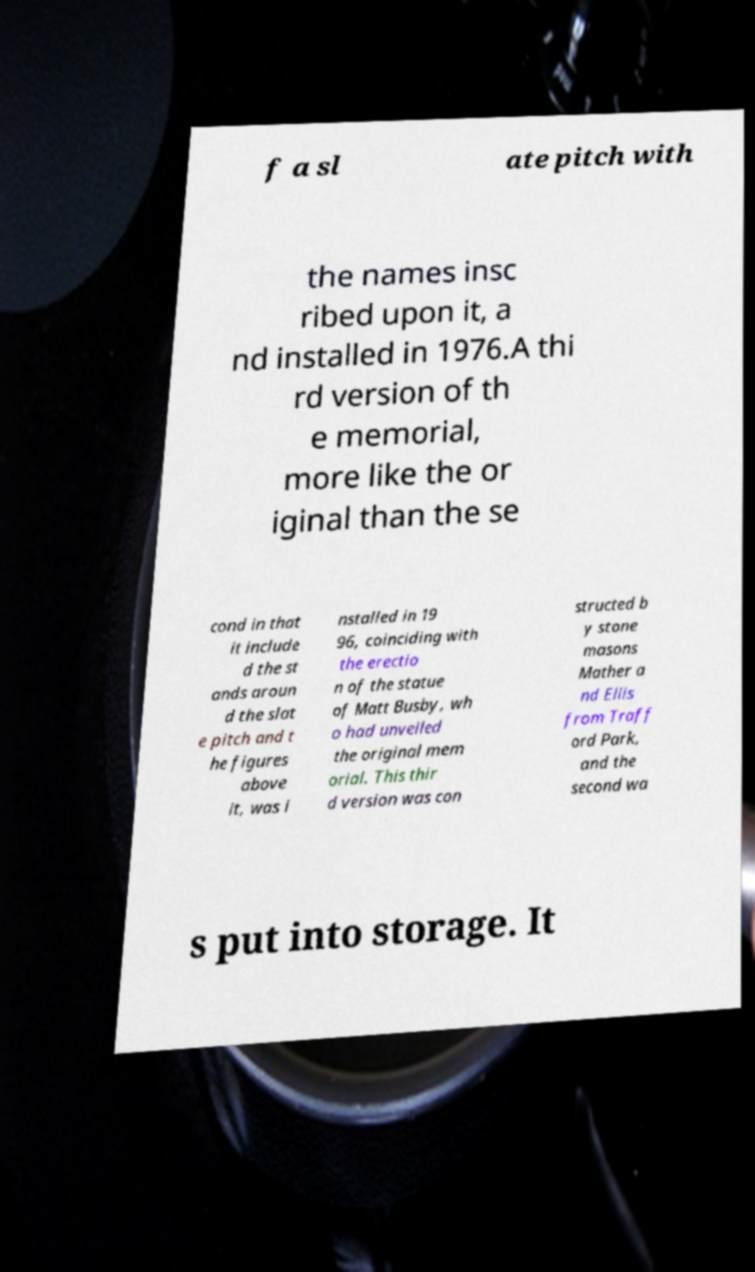I need the written content from this picture converted into text. Can you do that? f a sl ate pitch with the names insc ribed upon it, a nd installed in 1976.A thi rd version of th e memorial, more like the or iginal than the se cond in that it include d the st ands aroun d the slat e pitch and t he figures above it, was i nstalled in 19 96, coinciding with the erectio n of the statue of Matt Busby, wh o had unveiled the original mem orial. This thir d version was con structed b y stone masons Mather a nd Ellis from Traff ord Park, and the second wa s put into storage. It 